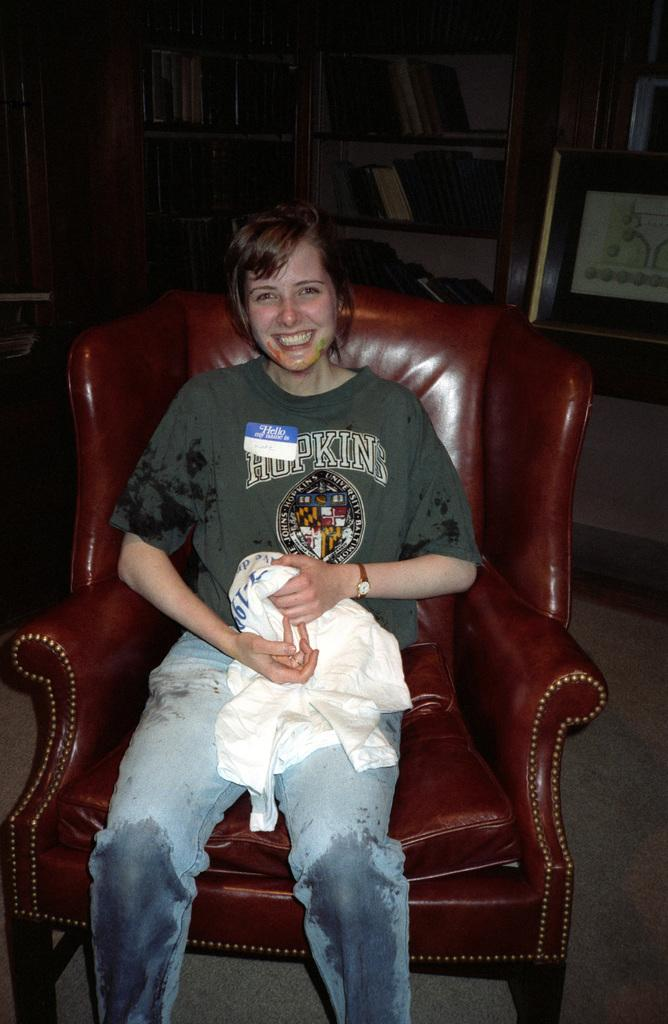What is the person in the image doing? There is a person sitting on a chair in the image. What can be seen in the background of the image? There is a rack in the background of the image. What is stored on the rack? There are books kept in the rack. What type of iron is being used to press the books in the image? There is no iron or pressing of books visible in the image; it only shows a person sitting on a chair and a rack with books in the background. 